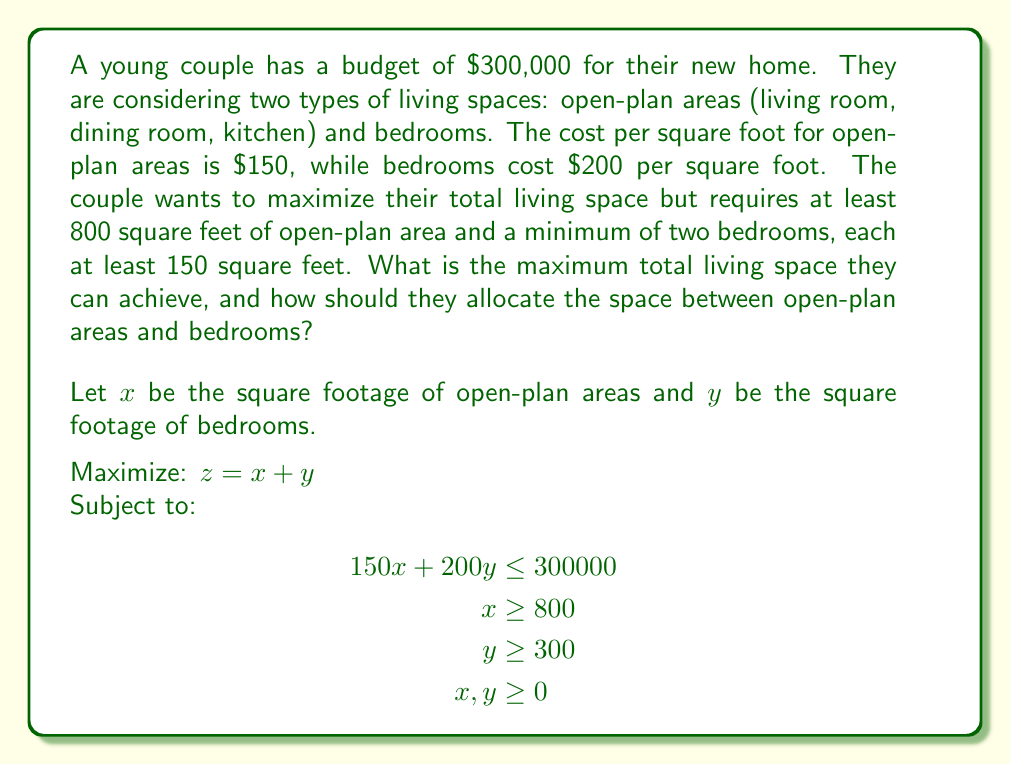Give your solution to this math problem. To solve this linear programming problem, we'll use the graphical method:

1. Plot the constraints:
   - Budget constraint: $150x + 200y = 300000$ or $y = 1500 - 0.75x$
   - Minimum open-plan area: $x = 800$
   - Minimum bedroom area: $y = 300$

2. Identify the feasible region bounded by these constraints.

3. Find the vertices of the feasible region:
   A: (800, 300)
   B: (800, 900)
   C: (1600, 300)

4. Evaluate the objective function $z = x + y$ at each vertex:
   A: $z_A = 800 + 300 = 1100$
   B: $z_B = 800 + 900 = 1700$
   C: $z_C = 1600 + 300 = 1900$

5. The maximum value of $z$ occurs at point C (1600, 300).

Therefore, the maximum total living space is 1900 square feet, with 1600 square feet allocated to open-plan areas and 300 square feet to bedrooms (two 150 square foot bedrooms).

To verify the budget constraint:
$(1600 \times 150) + (300 \times 200) = 240000 + 60000 = 300000$

This solution satisfies all constraints and maximizes the total living space.

[asy]
import graph;
size(200);
xaxis("Open-plan area (sq ft)", 0, 2000, Arrow);
yaxis("Bedroom area (sq ft)", 0, 1000, Arrow);

draw((0,1500)--(2000,0), blue);
draw((800,0)--(800,1000), red);
draw((0,300)--(2000,300), green);

label("Budget constraint", (1000,750), blue);
label("Min open-plan", (850,500), red);
label("Min bedroom", (1000,350), green);

dot((800,300));
dot((800,900));
dot((1600,300));

label("A", (780,280));
label("B", (780,920));
label("C", (1620,280));

fill((800,300)--(800,900)--(1600,300)--cycle, lightgray);
label("Feasible region", (1000,500));
[/asy]
Answer: The maximum total living space is 1900 square feet, with 1600 square feet allocated to open-plan areas and 300 square feet to bedrooms. 